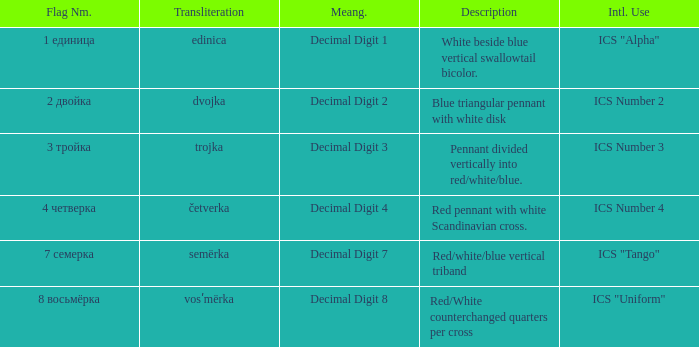What is the name of the flag that means decimal digit 2? 2 двойка. 